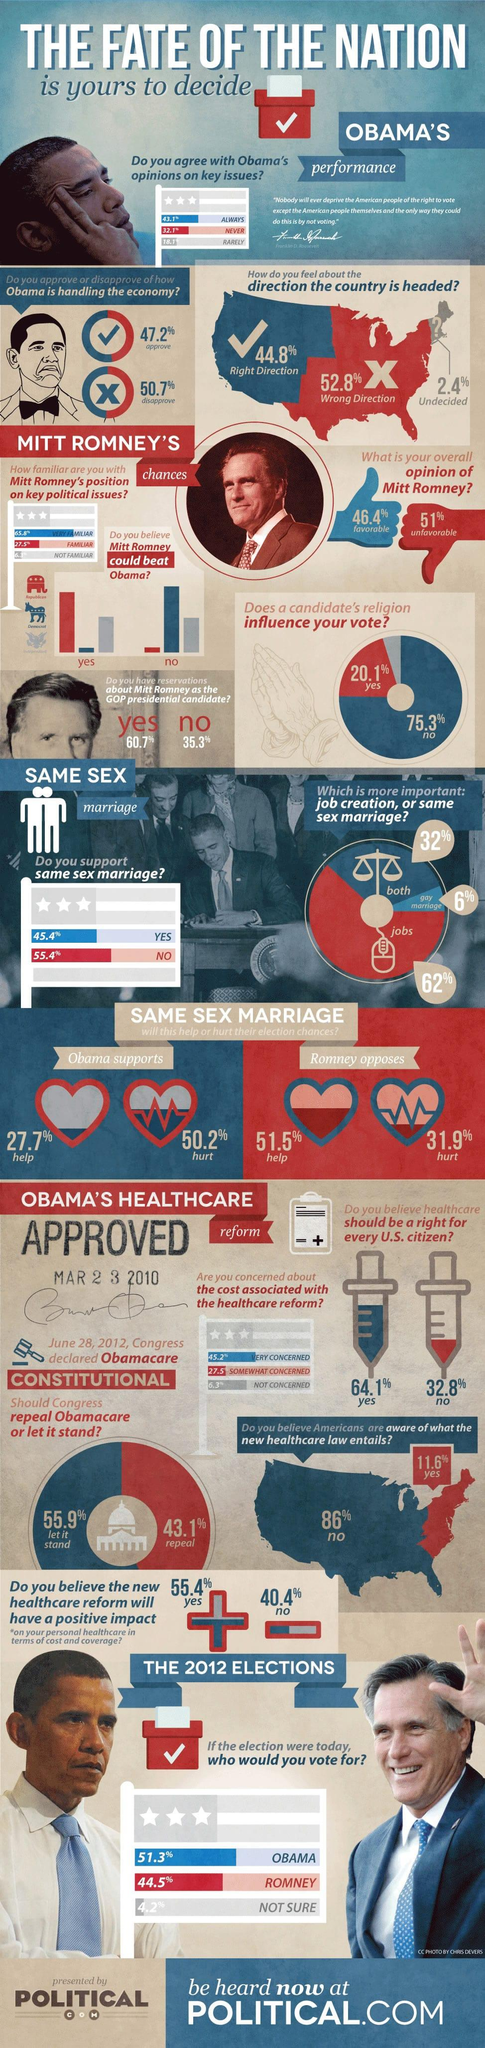List a handful of essential elements in this visual. According to a recent survey, 64.1% of Americans believe that healthcare should be a right for every US citizen. According to a survey, 43.1% of Americans always agree with President Obama's opinions on key issues of the nation. According to a survey, 50.7% of Americans disapprove of how President Obama is handling the economy. A survey showed that 46.4% of Americans have a favorable opinion of Mitt Romney. According to the survey, 62% of Americans believed that job creation was more important than same-sex marriage. 